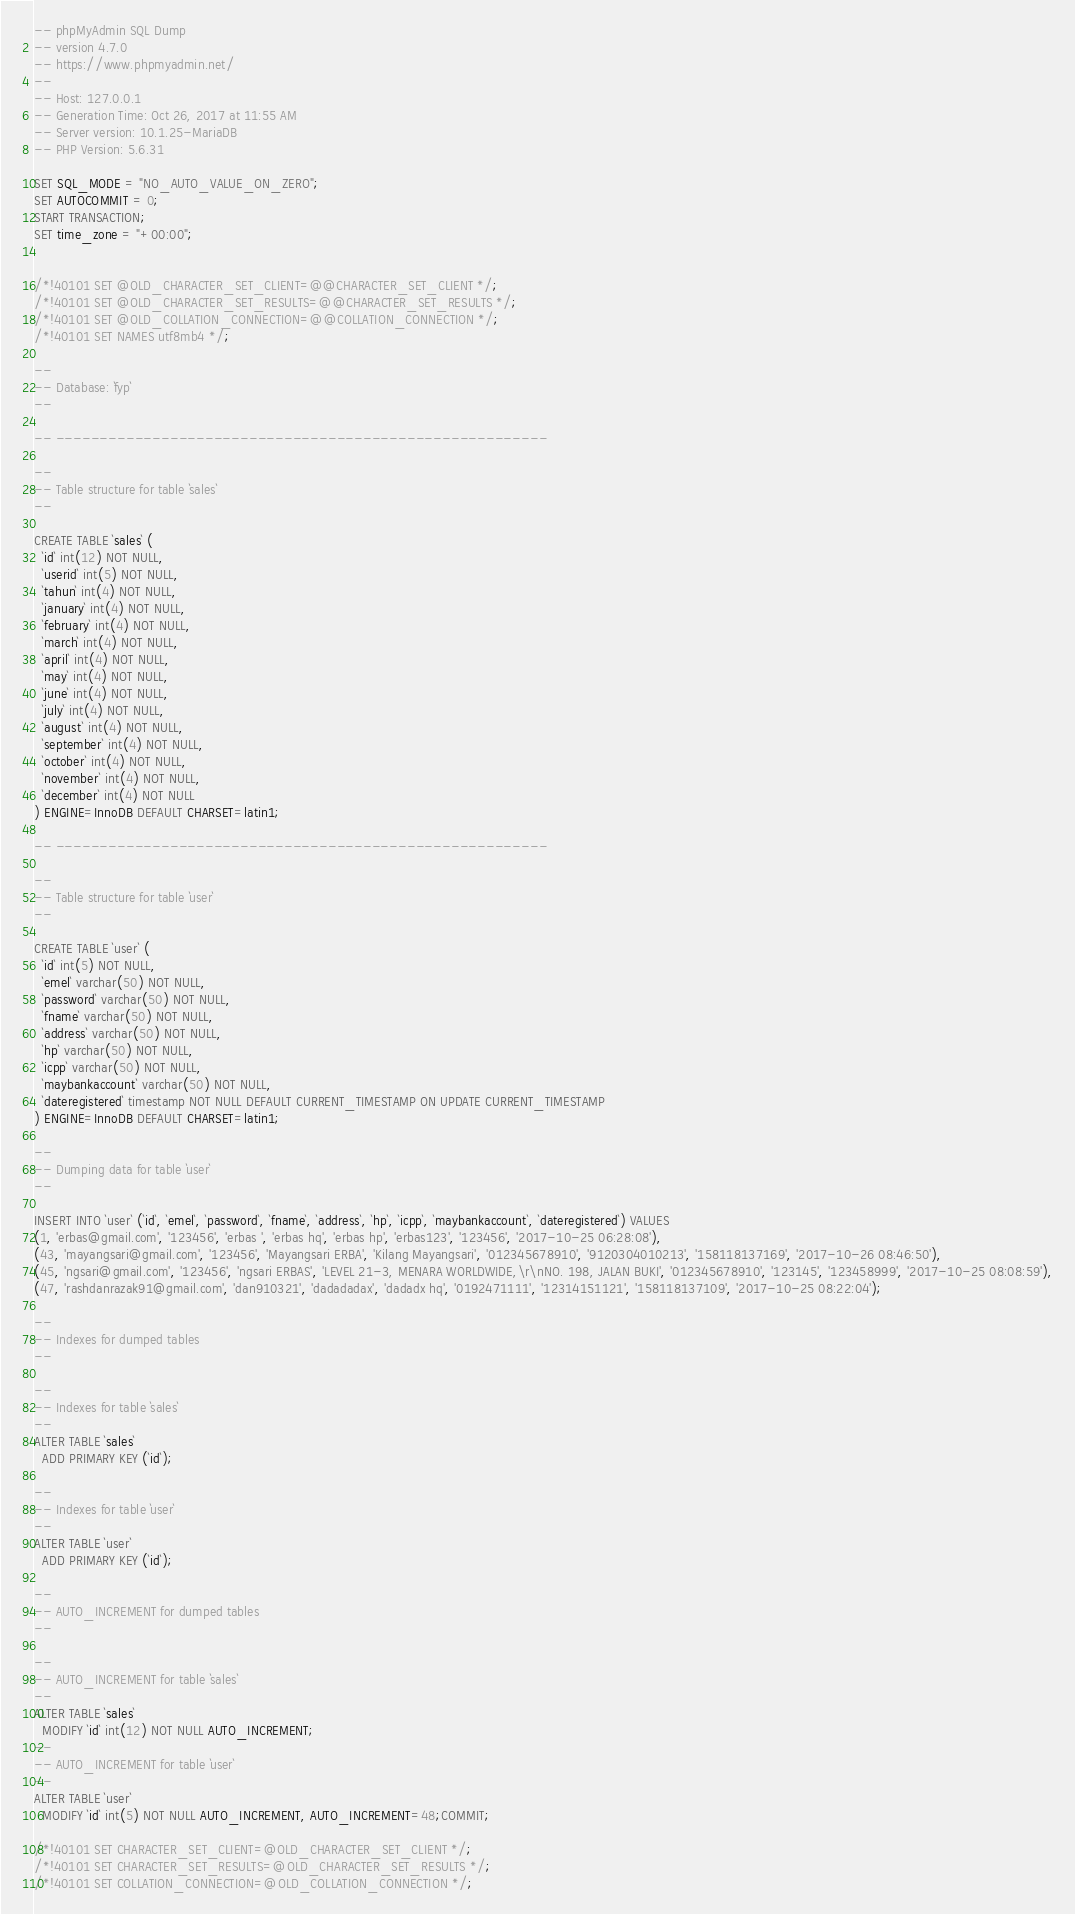Convert code to text. <code><loc_0><loc_0><loc_500><loc_500><_SQL_>-- phpMyAdmin SQL Dump
-- version 4.7.0
-- https://www.phpmyadmin.net/
--
-- Host: 127.0.0.1
-- Generation Time: Oct 26, 2017 at 11:55 AM
-- Server version: 10.1.25-MariaDB
-- PHP Version: 5.6.31

SET SQL_MODE = "NO_AUTO_VALUE_ON_ZERO";
SET AUTOCOMMIT = 0;
START TRANSACTION;
SET time_zone = "+00:00";


/*!40101 SET @OLD_CHARACTER_SET_CLIENT=@@CHARACTER_SET_CLIENT */;
/*!40101 SET @OLD_CHARACTER_SET_RESULTS=@@CHARACTER_SET_RESULTS */;
/*!40101 SET @OLD_COLLATION_CONNECTION=@@COLLATION_CONNECTION */;
/*!40101 SET NAMES utf8mb4 */;

--
-- Database: `fyp`
--

-- --------------------------------------------------------

--
-- Table structure for table `sales`
--

CREATE TABLE `sales` (
  `id` int(12) NOT NULL,
  `userid` int(5) NOT NULL,
  `tahun` int(4) NOT NULL,
  `january` int(4) NOT NULL,
  `february` int(4) NOT NULL,
  `march` int(4) NOT NULL,
  `april` int(4) NOT NULL,
  `may` int(4) NOT NULL,
  `june` int(4) NOT NULL,
  `july` int(4) NOT NULL,
  `august` int(4) NOT NULL,
  `september` int(4) NOT NULL,
  `october` int(4) NOT NULL,
  `november` int(4) NOT NULL,
  `december` int(4) NOT NULL
) ENGINE=InnoDB DEFAULT CHARSET=latin1;

-- --------------------------------------------------------

--
-- Table structure for table `user`
--

CREATE TABLE `user` (
  `id` int(5) NOT NULL,
  `emel` varchar(50) NOT NULL,
  `password` varchar(50) NOT NULL,
  `fname` varchar(50) NOT NULL,
  `address` varchar(50) NOT NULL,
  `hp` varchar(50) NOT NULL,
  `icpp` varchar(50) NOT NULL,
  `maybankaccount` varchar(50) NOT NULL,
  `dateregistered` timestamp NOT NULL DEFAULT CURRENT_TIMESTAMP ON UPDATE CURRENT_TIMESTAMP
) ENGINE=InnoDB DEFAULT CHARSET=latin1;

--
-- Dumping data for table `user`
--

INSERT INTO `user` (`id`, `emel`, `password`, `fname`, `address`, `hp`, `icpp`, `maybankaccount`, `dateregistered`) VALUES
(1, 'erbas@gmail.com', '123456', 'erbas ', 'erbas hq', 'erbas hp', 'erbas123', '123456', '2017-10-25 06:28:08'),
(43, 'mayangsari@gmail.com', '123456', 'Mayangsari ERBA', 'Kilang Mayangsari', '012345678910', '9120304010213', '158118137169', '2017-10-26 08:46:50'),
(45, 'ngsari@gmail.com', '123456', 'ngsari ERBAS', 'LEVEL 21-3, MENARA WORLDWIDE,\r\nNO. 198, JALAN BUKI', '012345678910', '123145', '123458999', '2017-10-25 08:08:59'),
(47, 'rashdanrazak91@gmail.com', 'dan910321', 'dadadadax', 'dadadx hq', '0192471111', '12314151121', '158118137109', '2017-10-25 08:22:04');

--
-- Indexes for dumped tables
--

--
-- Indexes for table `sales`
--
ALTER TABLE `sales`
  ADD PRIMARY KEY (`id`);

--
-- Indexes for table `user`
--
ALTER TABLE `user`
  ADD PRIMARY KEY (`id`);

--
-- AUTO_INCREMENT for dumped tables
--

--
-- AUTO_INCREMENT for table `sales`
--
ALTER TABLE `sales`
  MODIFY `id` int(12) NOT NULL AUTO_INCREMENT;
--
-- AUTO_INCREMENT for table `user`
--
ALTER TABLE `user`
  MODIFY `id` int(5) NOT NULL AUTO_INCREMENT, AUTO_INCREMENT=48;COMMIT;

/*!40101 SET CHARACTER_SET_CLIENT=@OLD_CHARACTER_SET_CLIENT */;
/*!40101 SET CHARACTER_SET_RESULTS=@OLD_CHARACTER_SET_RESULTS */;
/*!40101 SET COLLATION_CONNECTION=@OLD_COLLATION_CONNECTION */;
</code> 